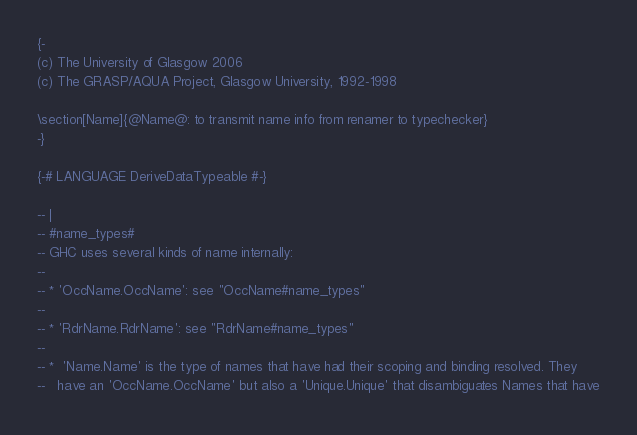Convert code to text. <code><loc_0><loc_0><loc_500><loc_500><_Haskell_>{-
(c) The University of Glasgow 2006
(c) The GRASP/AQUA Project, Glasgow University, 1992-1998

\section[Name]{@Name@: to transmit name info from renamer to typechecker}
-}

{-# LANGUAGE DeriveDataTypeable #-}

-- |
-- #name_types#
-- GHC uses several kinds of name internally:
--
-- * 'OccName.OccName': see "OccName#name_types"
--
-- * 'RdrName.RdrName': see "RdrName#name_types"
--
-- *  'Name.Name' is the type of names that have had their scoping and binding resolved. They
--   have an 'OccName.OccName' but also a 'Unique.Unique' that disambiguates Names that have</code> 